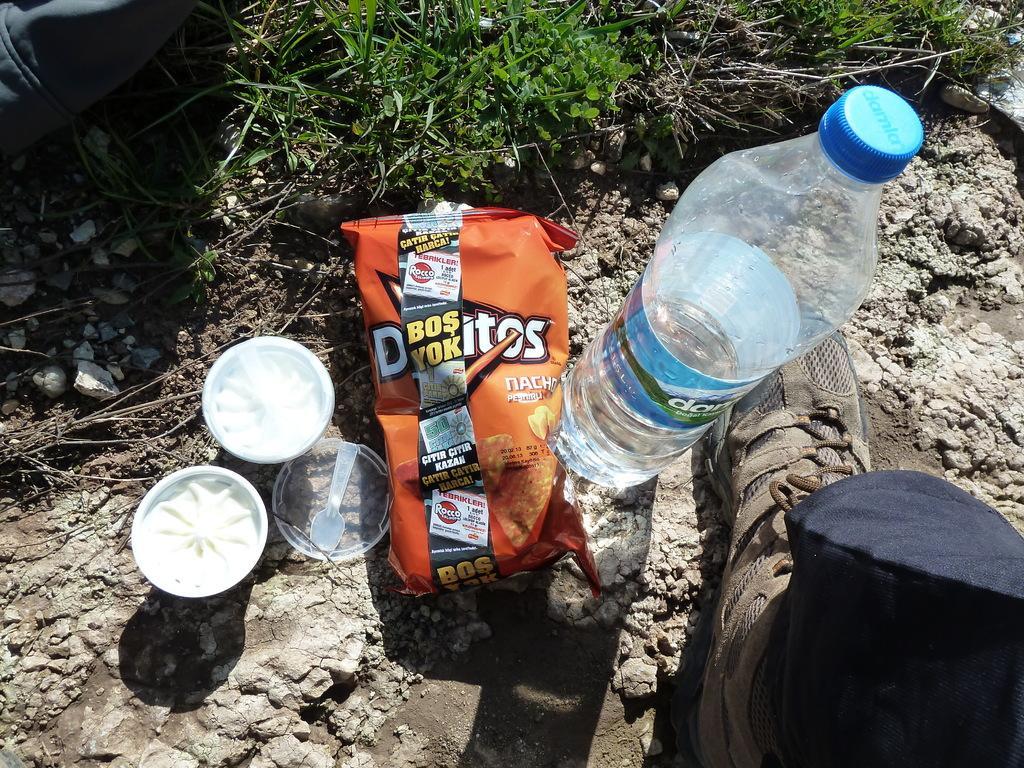Please provide a concise description of this image. In this picture we can see bottle, chips packet, bowl, spoon, person's shoe on floor which is rocks and aside to this there is tree. 